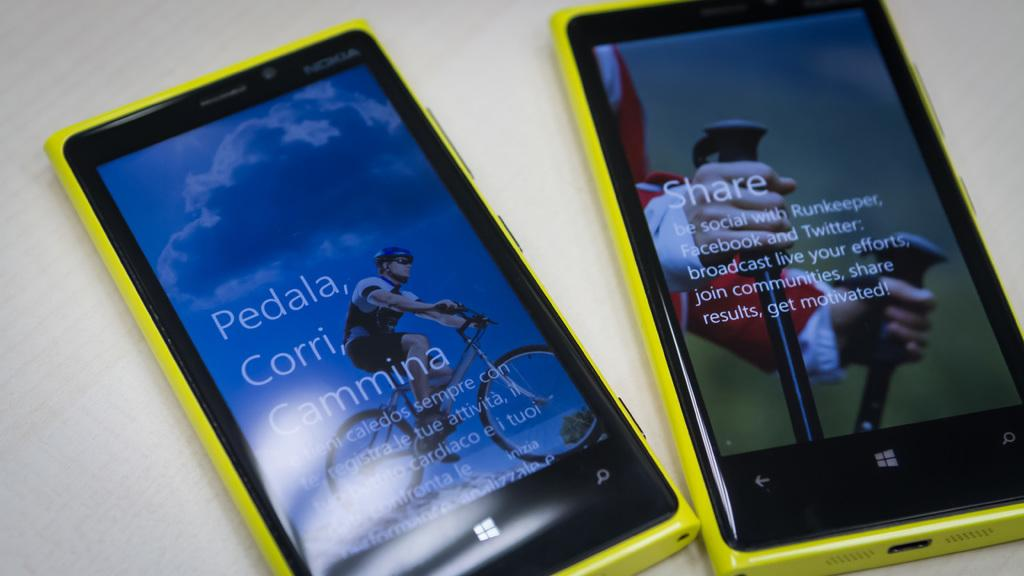<image>
Summarize the visual content of the image. Two yellow cellphones with one asking one to share on RunKeeper, Facebook and Twitter. 